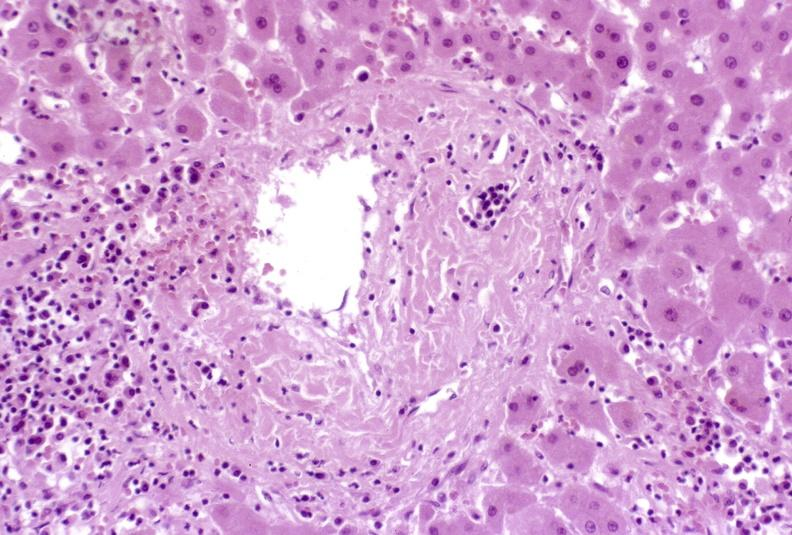does stillborn cord around neck show severe acute rejection?
Answer the question using a single word or phrase. No 